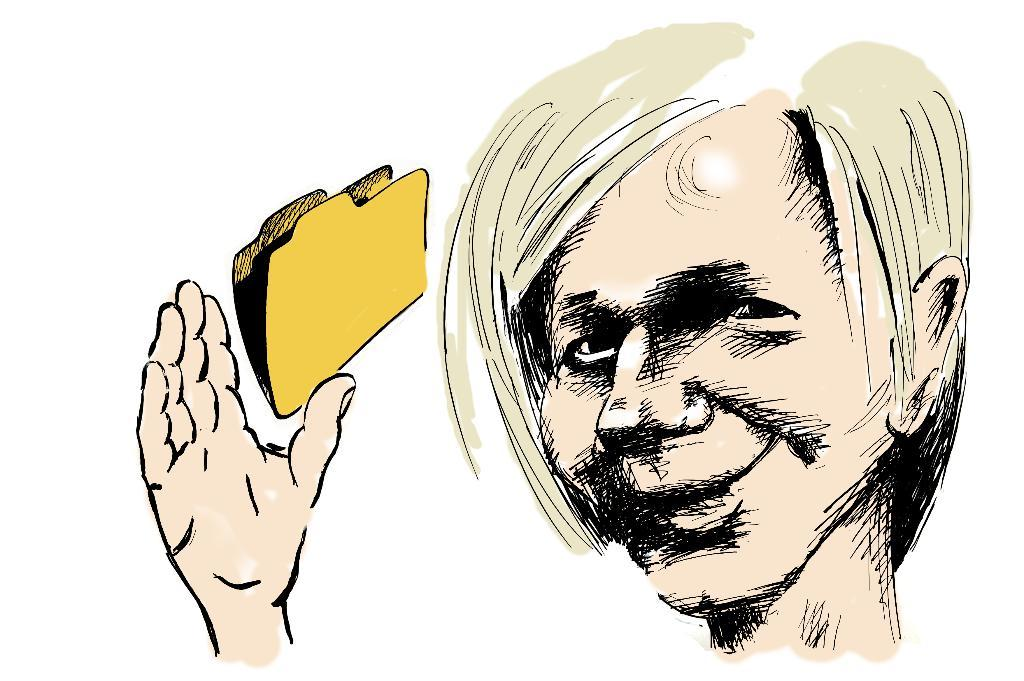What type of image is present in the picture? There is an animated image of a person in the picture. What other object can be seen in the picture? There is a file icon in the picture. What is the color of the backdrop in the image? The backdrop of the image is white in color. How many drawers are visible in the image? There are no drawers present in the image. What type of neck accessory is the person wearing in the image? The animated person in the image does not have a physical body, so there is no neck accessory to be worn. 